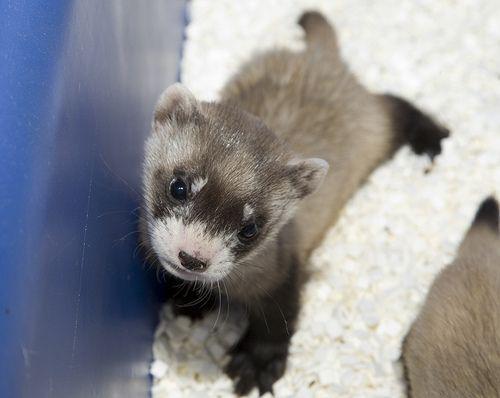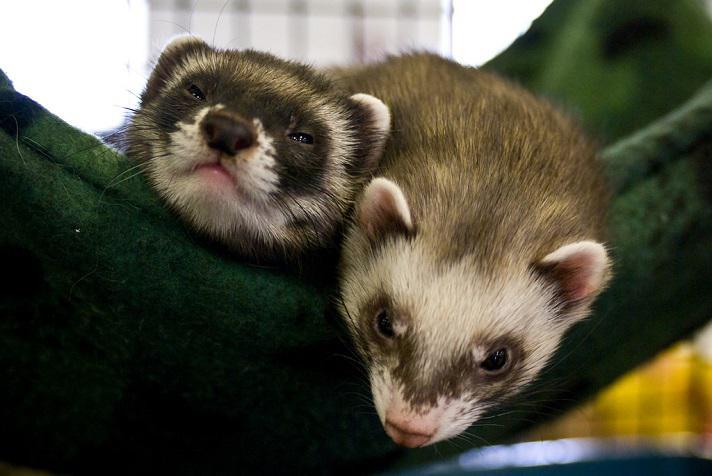The first image is the image on the left, the second image is the image on the right. For the images shown, is this caption "There are exactly two ferrets in both images." true? Answer yes or no. No. The first image is the image on the left, the second image is the image on the right. For the images shown, is this caption "The left image includes at least one ferret standing on all fours, and the right image contains two side-by-side ferrets with at least one having sleepy eyes." true? Answer yes or no. Yes. 